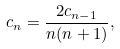Convert formula to latex. <formula><loc_0><loc_0><loc_500><loc_500>c _ { n } = \frac { 2 c _ { n - 1 } } { n ( n + 1 ) } ,</formula> 